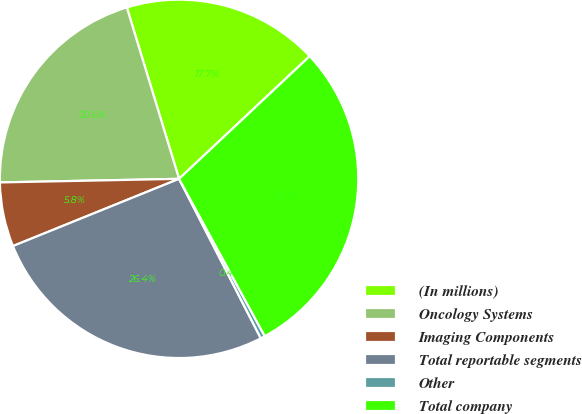Convert chart to OTSL. <chart><loc_0><loc_0><loc_500><loc_500><pie_chart><fcel>(In millions)<fcel>Oncology Systems<fcel>Imaging Components<fcel>Total reportable segments<fcel>Other<fcel>Total company<nl><fcel>17.71%<fcel>20.61%<fcel>5.8%<fcel>26.42%<fcel>0.4%<fcel>29.06%<nl></chart> 